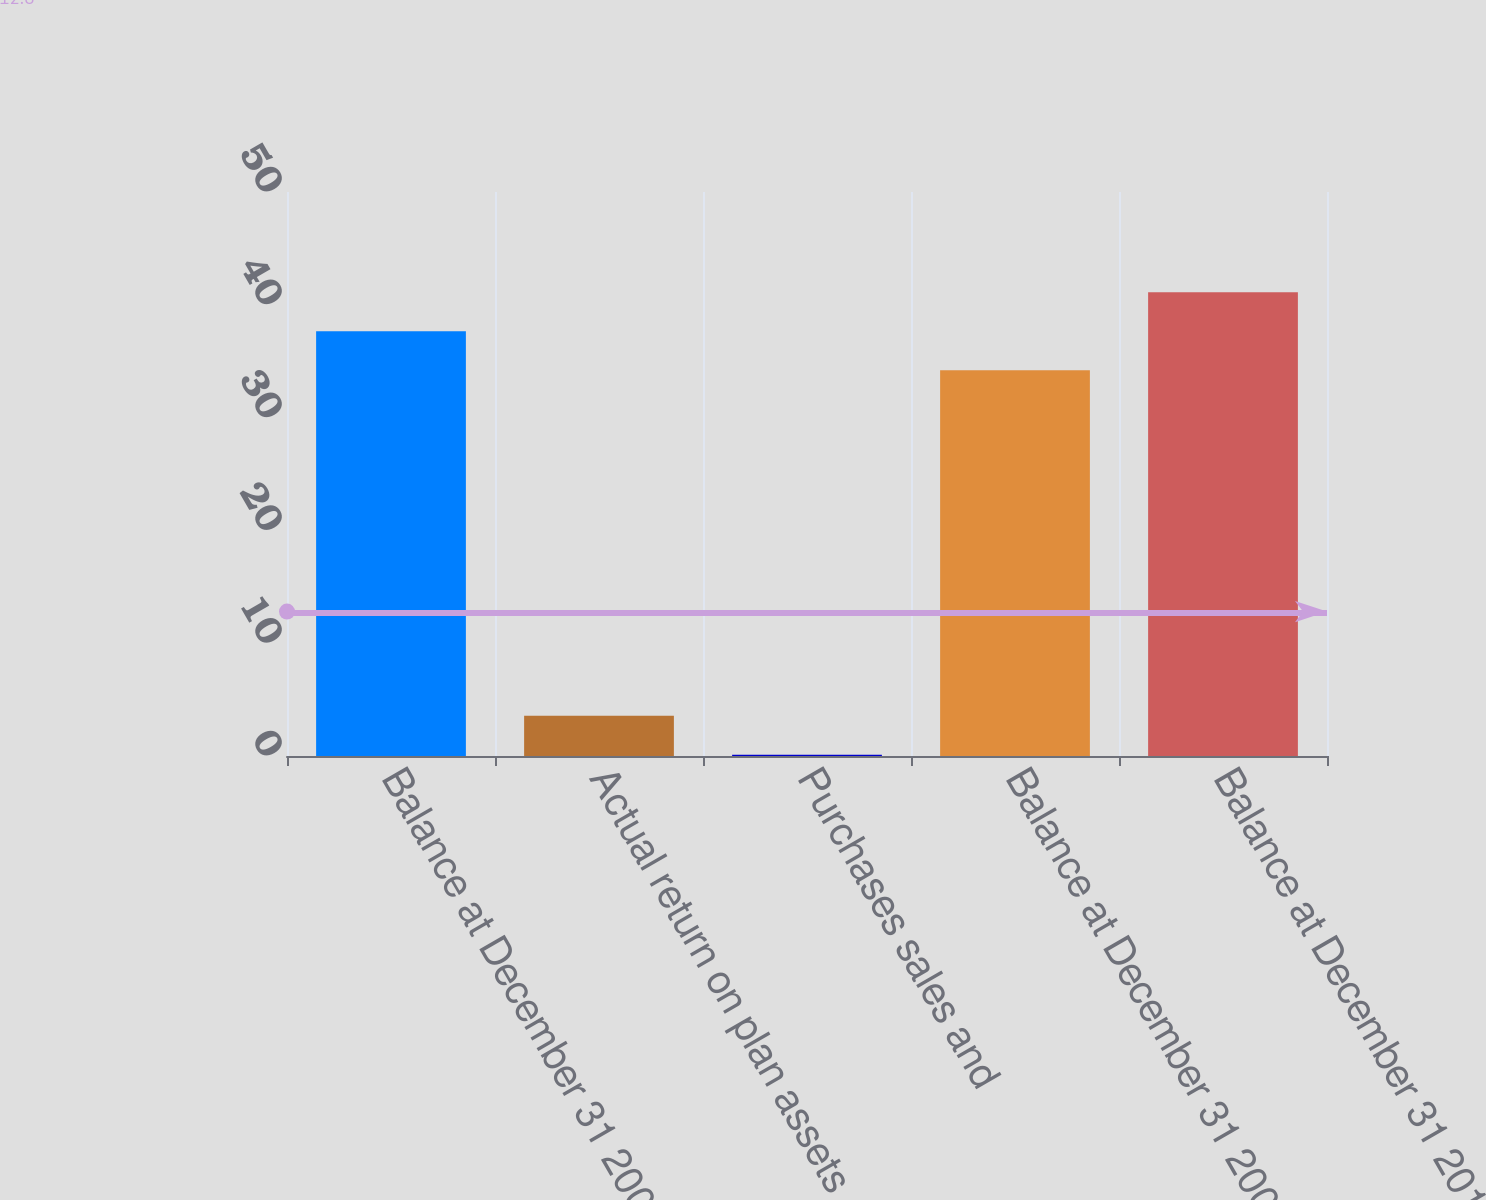Convert chart to OTSL. <chart><loc_0><loc_0><loc_500><loc_500><bar_chart><fcel>Balance at December 31 2008<fcel>Actual return on plan assets<fcel>Purchases sales and<fcel>Balance at December 31 2009<fcel>Balance at December 31 2010<nl><fcel>37.66<fcel>3.56<fcel>0.1<fcel>34.2<fcel>41.12<nl></chart> 